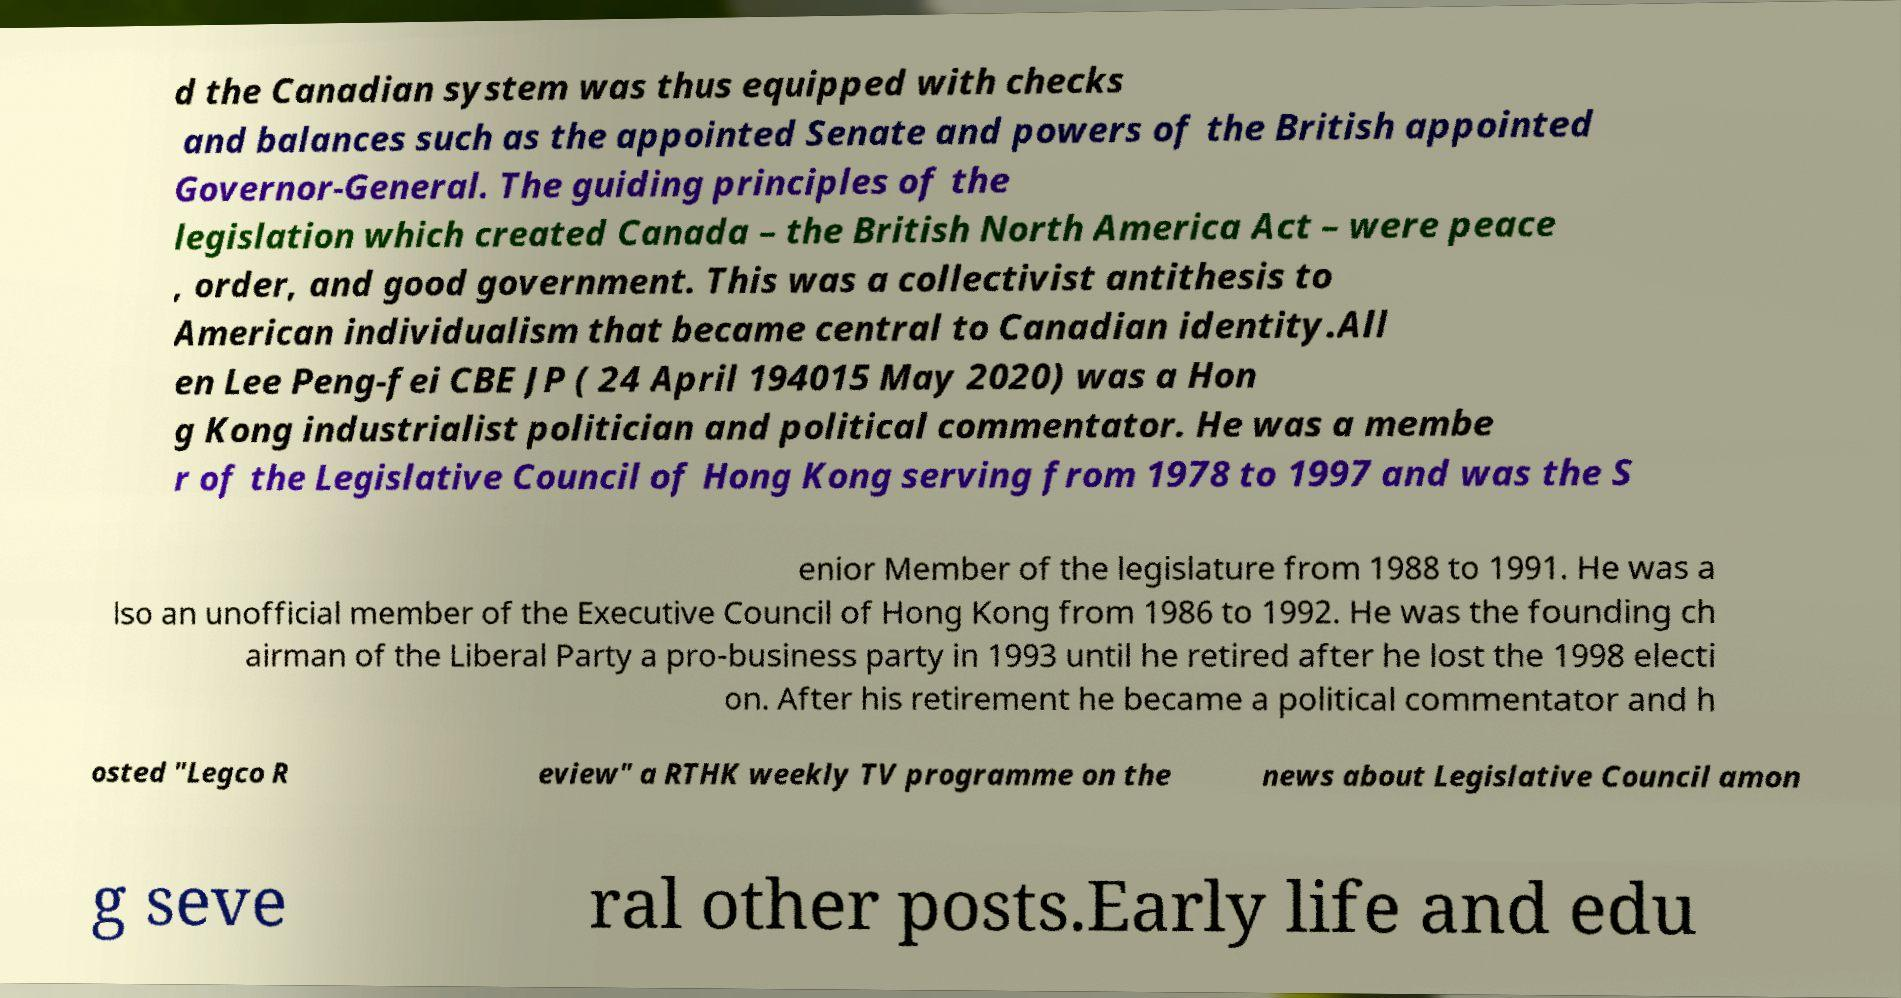Could you extract and type out the text from this image? d the Canadian system was thus equipped with checks and balances such as the appointed Senate and powers of the British appointed Governor-General. The guiding principles of the legislation which created Canada – the British North America Act – were peace , order, and good government. This was a collectivist antithesis to American individualism that became central to Canadian identity.All en Lee Peng-fei CBE JP ( 24 April 194015 May 2020) was a Hon g Kong industrialist politician and political commentator. He was a membe r of the Legislative Council of Hong Kong serving from 1978 to 1997 and was the S enior Member of the legislature from 1988 to 1991. He was a lso an unofficial member of the Executive Council of Hong Kong from 1986 to 1992. He was the founding ch airman of the Liberal Party a pro-business party in 1993 until he retired after he lost the 1998 electi on. After his retirement he became a political commentator and h osted "Legco R eview" a RTHK weekly TV programme on the news about Legislative Council amon g seve ral other posts.Early life and edu 